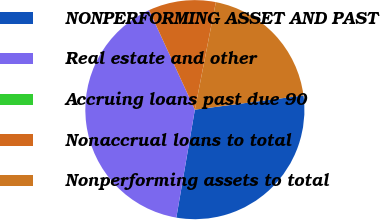<chart> <loc_0><loc_0><loc_500><loc_500><pie_chart><fcel>NONPERFORMING ASSET AND PAST<fcel>Real estate and other<fcel>Accruing loans past due 90<fcel>Nonaccrual loans to total<fcel>Nonperforming assets to total<nl><fcel>29.78%<fcel>40.43%<fcel>0.0%<fcel>9.93%<fcel>19.86%<nl></chart> 